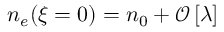<formula> <loc_0><loc_0><loc_500><loc_500>\begin{array} { r } { n _ { e } ( \xi = 0 ) = n _ { 0 } + \mathcal { O } \left [ \lambda \right ] } \end{array}</formula> 